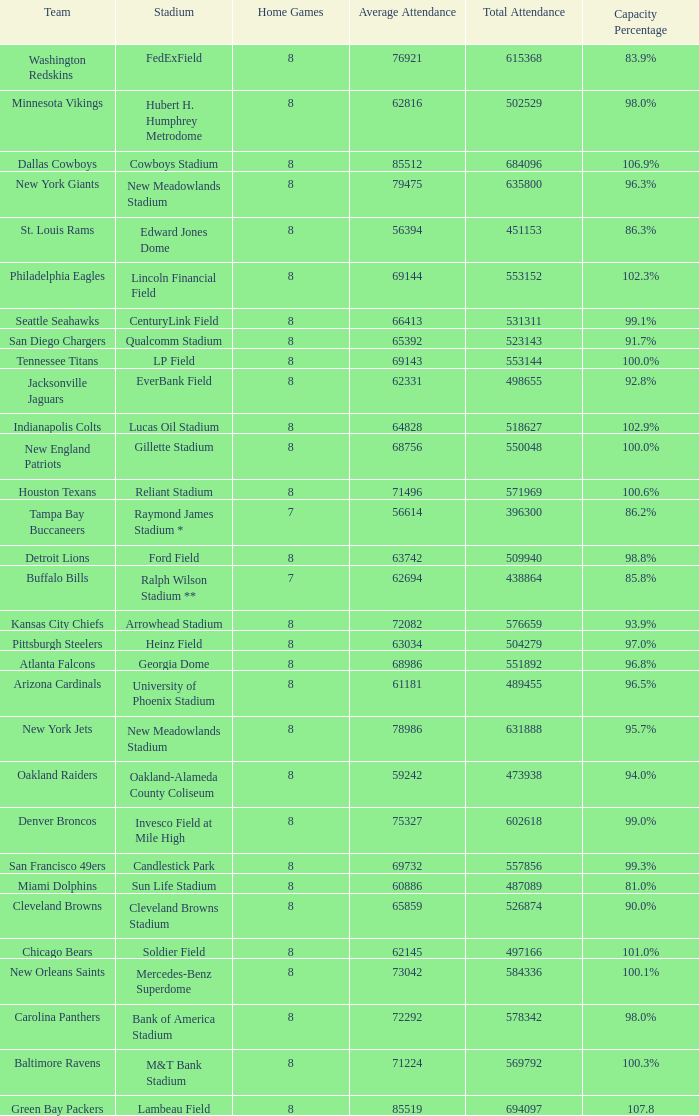How many home games are listed when the average attendance is 79475? 1.0. 